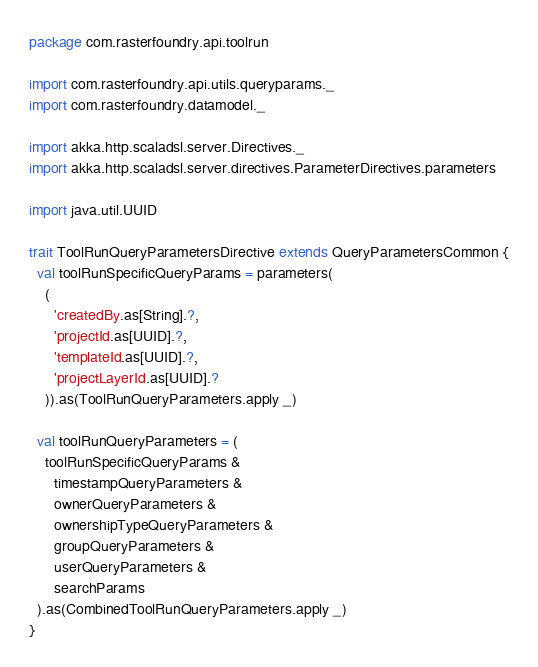Convert code to text. <code><loc_0><loc_0><loc_500><loc_500><_Scala_>package com.rasterfoundry.api.toolrun

import com.rasterfoundry.api.utils.queryparams._
import com.rasterfoundry.datamodel._

import akka.http.scaladsl.server.Directives._
import akka.http.scaladsl.server.directives.ParameterDirectives.parameters

import java.util.UUID

trait ToolRunQueryParametersDirective extends QueryParametersCommon {
  val toolRunSpecificQueryParams = parameters(
    (
      'createdBy.as[String].?,
      'projectId.as[UUID].?,
      'templateId.as[UUID].?,
      'projectLayerId.as[UUID].?
    )).as(ToolRunQueryParameters.apply _)

  val toolRunQueryParameters = (
    toolRunSpecificQueryParams &
      timestampQueryParameters &
      ownerQueryParameters &
      ownershipTypeQueryParameters &
      groupQueryParameters &
      userQueryParameters &
      searchParams
  ).as(CombinedToolRunQueryParameters.apply _)
}
</code> 